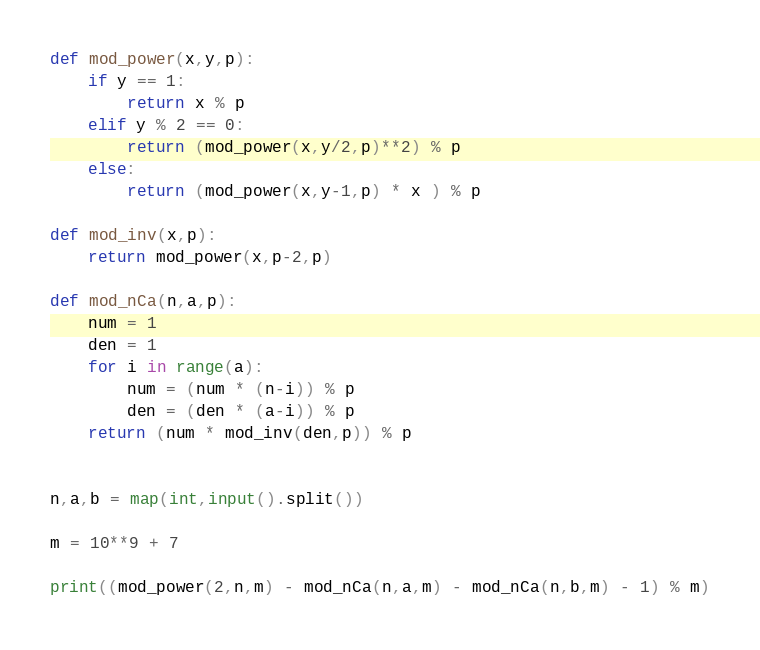<code> <loc_0><loc_0><loc_500><loc_500><_Python_>def mod_power(x,y,p):
    if y == 1:
        return x % p
    elif y % 2 == 0:
        return (mod_power(x,y/2,p)**2) % p
    else:
        return (mod_power(x,y-1,p) * x ) % p

def mod_inv(x,p):
    return mod_power(x,p-2,p)

def mod_nCa(n,a,p):
    num = 1
    den = 1
    for i in range(a):
        num = (num * (n-i)) % p
        den = (den * (a-i)) % p
    return (num * mod_inv(den,p)) % p


n,a,b = map(int,input().split())

m = 10**9 + 7

print((mod_power(2,n,m) - mod_nCa(n,a,m) - mod_nCa(n,b,m) - 1) % m)</code> 